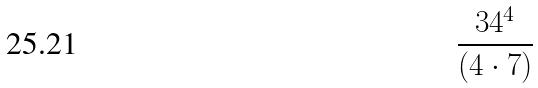Convert formula to latex. <formula><loc_0><loc_0><loc_500><loc_500>\frac { 3 4 ^ { 4 } } { ( 4 \cdot 7 ) }</formula> 